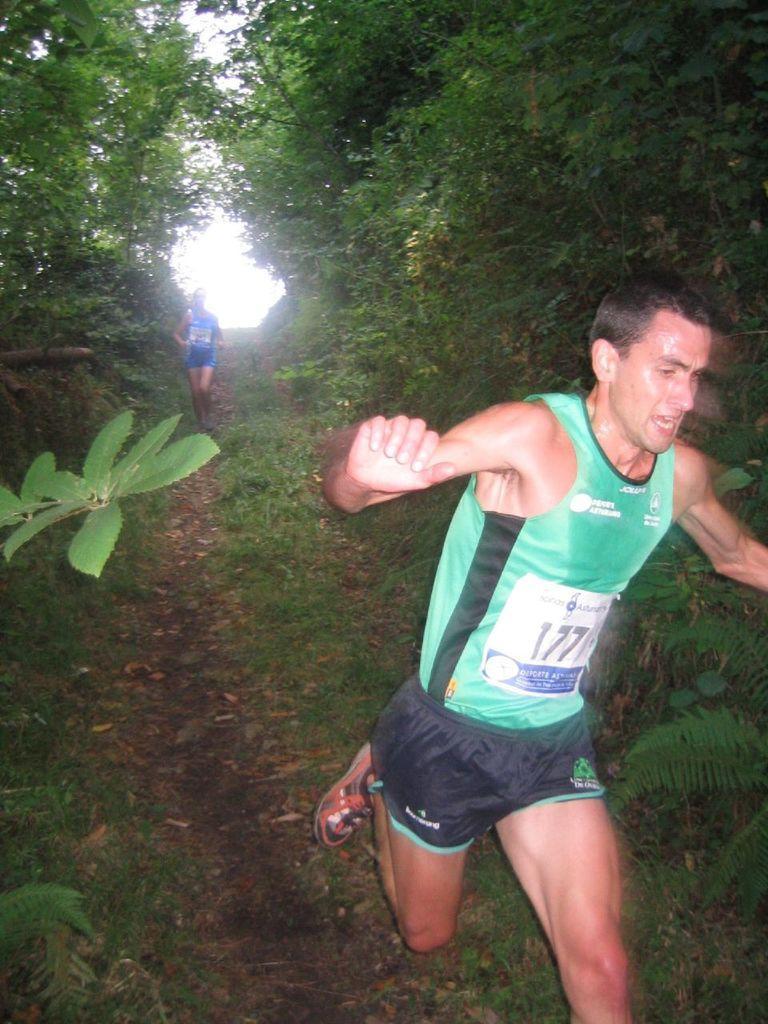Describe this image in one or two sentences. In the image we can see there are people running on the ground and the ground is covered with grass. There are trees. 